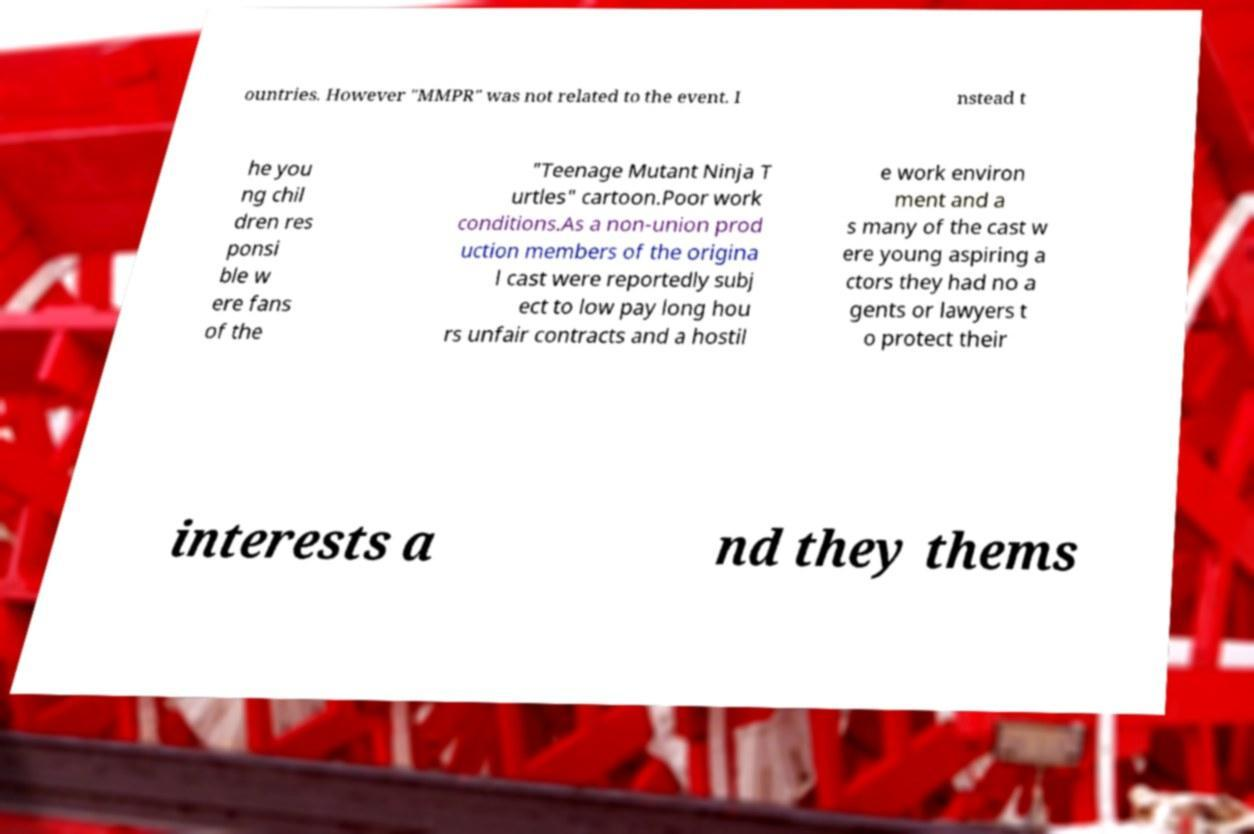Could you extract and type out the text from this image? ountries. However "MMPR" was not related to the event. I nstead t he you ng chil dren res ponsi ble w ere fans of the "Teenage Mutant Ninja T urtles" cartoon.Poor work conditions.As a non-union prod uction members of the origina l cast were reportedly subj ect to low pay long hou rs unfair contracts and a hostil e work environ ment and a s many of the cast w ere young aspiring a ctors they had no a gents or lawyers t o protect their interests a nd they thems 